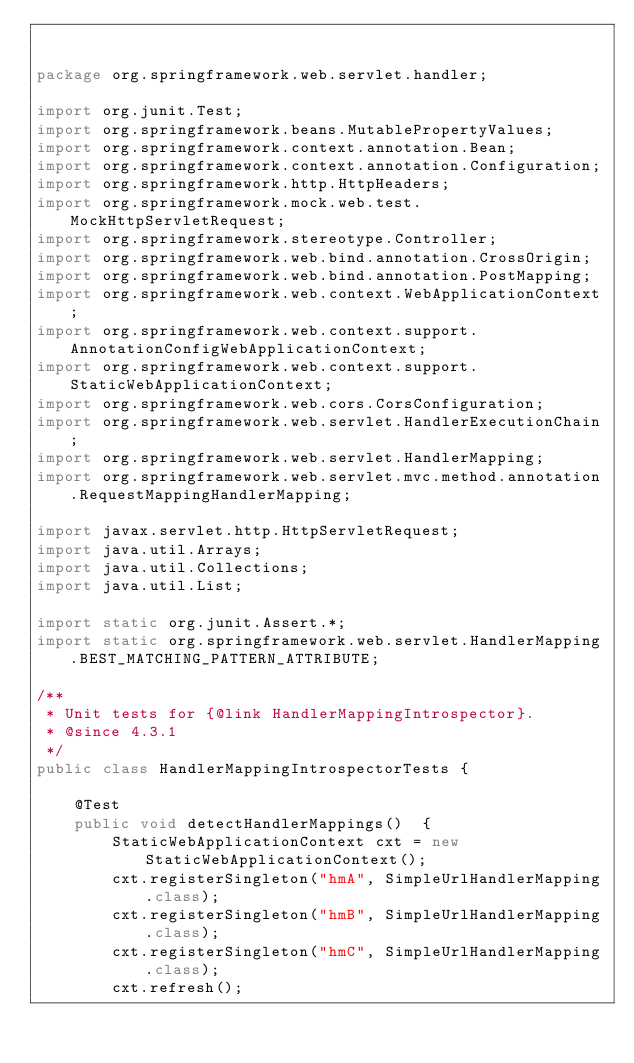Convert code to text. <code><loc_0><loc_0><loc_500><loc_500><_Java_>

package org.springframework.web.servlet.handler;

import org.junit.Test;
import org.springframework.beans.MutablePropertyValues;
import org.springframework.context.annotation.Bean;
import org.springframework.context.annotation.Configuration;
import org.springframework.http.HttpHeaders;
import org.springframework.mock.web.test.MockHttpServletRequest;
import org.springframework.stereotype.Controller;
import org.springframework.web.bind.annotation.CrossOrigin;
import org.springframework.web.bind.annotation.PostMapping;
import org.springframework.web.context.WebApplicationContext;
import org.springframework.web.context.support.AnnotationConfigWebApplicationContext;
import org.springframework.web.context.support.StaticWebApplicationContext;
import org.springframework.web.cors.CorsConfiguration;
import org.springframework.web.servlet.HandlerExecutionChain;
import org.springframework.web.servlet.HandlerMapping;
import org.springframework.web.servlet.mvc.method.annotation.RequestMappingHandlerMapping;

import javax.servlet.http.HttpServletRequest;
import java.util.Arrays;
import java.util.Collections;
import java.util.List;

import static org.junit.Assert.*;
import static org.springframework.web.servlet.HandlerMapping.BEST_MATCHING_PATTERN_ATTRIBUTE;

/**
 * Unit tests for {@link HandlerMappingIntrospector}.
 * @since 4.3.1
 */
public class HandlerMappingIntrospectorTests {

	@Test
	public void detectHandlerMappings()  {
		StaticWebApplicationContext cxt = new StaticWebApplicationContext();
		cxt.registerSingleton("hmA", SimpleUrlHandlerMapping.class);
		cxt.registerSingleton("hmB", SimpleUrlHandlerMapping.class);
		cxt.registerSingleton("hmC", SimpleUrlHandlerMapping.class);
		cxt.refresh();
</code> 